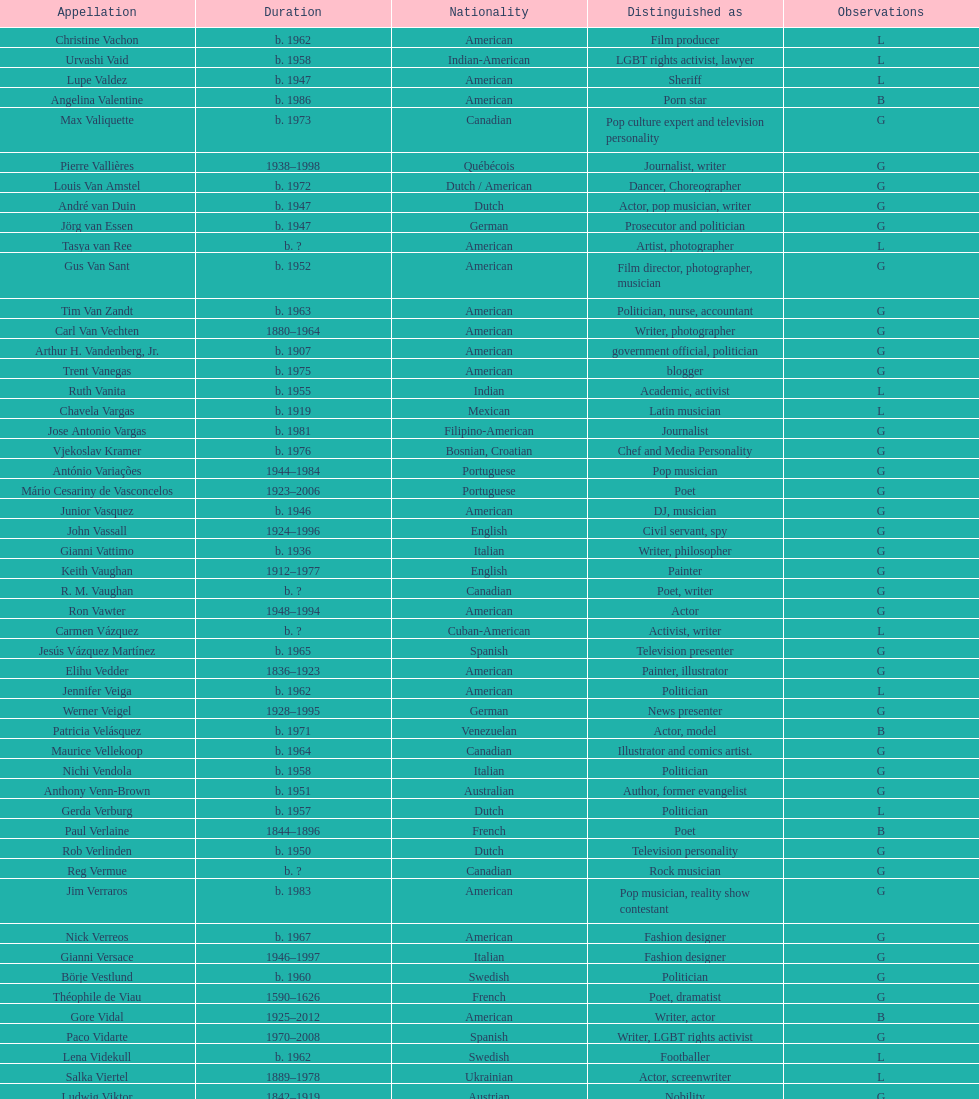Could you parse the entire table as a dict? {'header': ['Appellation', 'Duration', 'Nationality', 'Distinguished as', 'Observations'], 'rows': [['Christine Vachon', 'b. 1962', 'American', 'Film producer', 'L'], ['Urvashi Vaid', 'b. 1958', 'Indian-American', 'LGBT rights activist, lawyer', 'L'], ['Lupe Valdez', 'b. 1947', 'American', 'Sheriff', 'L'], ['Angelina Valentine', 'b. 1986', 'American', 'Porn star', 'B'], ['Max Valiquette', 'b. 1973', 'Canadian', 'Pop culture expert and television personality', 'G'], ['Pierre Vallières', '1938–1998', 'Québécois', 'Journalist, writer', 'G'], ['Louis Van Amstel', 'b. 1972', 'Dutch / American', 'Dancer, Choreographer', 'G'], ['André van Duin', 'b. 1947', 'Dutch', 'Actor, pop musician, writer', 'G'], ['Jörg van Essen', 'b. 1947', 'German', 'Prosecutor and politician', 'G'], ['Tasya van Ree', 'b.\xa0?', 'American', 'Artist, photographer', 'L'], ['Gus Van Sant', 'b. 1952', 'American', 'Film director, photographer, musician', 'G'], ['Tim Van Zandt', 'b. 1963', 'American', 'Politician, nurse, accountant', 'G'], ['Carl Van Vechten', '1880–1964', 'American', 'Writer, photographer', 'G'], ['Arthur H. Vandenberg, Jr.', 'b. 1907', 'American', 'government official, politician', 'G'], ['Trent Vanegas', 'b. 1975', 'American', 'blogger', 'G'], ['Ruth Vanita', 'b. 1955', 'Indian', 'Academic, activist', 'L'], ['Chavela Vargas', 'b. 1919', 'Mexican', 'Latin musician', 'L'], ['Jose Antonio Vargas', 'b. 1981', 'Filipino-American', 'Journalist', 'G'], ['Vjekoslav Kramer', 'b. 1976', 'Bosnian, Croatian', 'Chef and Media Personality', 'G'], ['António Variações', '1944–1984', 'Portuguese', 'Pop musician', 'G'], ['Mário Cesariny de Vasconcelos', '1923–2006', 'Portuguese', 'Poet', 'G'], ['Junior Vasquez', 'b. 1946', 'American', 'DJ, musician', 'G'], ['John Vassall', '1924–1996', 'English', 'Civil servant, spy', 'G'], ['Gianni Vattimo', 'b. 1936', 'Italian', 'Writer, philosopher', 'G'], ['Keith Vaughan', '1912–1977', 'English', 'Painter', 'G'], ['R. M. Vaughan', 'b.\xa0?', 'Canadian', 'Poet, writer', 'G'], ['Ron Vawter', '1948–1994', 'American', 'Actor', 'G'], ['Carmen Vázquez', 'b.\xa0?', 'Cuban-American', 'Activist, writer', 'L'], ['Jesús Vázquez Martínez', 'b. 1965', 'Spanish', 'Television presenter', 'G'], ['Elihu Vedder', '1836–1923', 'American', 'Painter, illustrator', 'G'], ['Jennifer Veiga', 'b. 1962', 'American', 'Politician', 'L'], ['Werner Veigel', '1928–1995', 'German', 'News presenter', 'G'], ['Patricia Velásquez', 'b. 1971', 'Venezuelan', 'Actor, model', 'B'], ['Maurice Vellekoop', 'b. 1964', 'Canadian', 'Illustrator and comics artist.', 'G'], ['Nichi Vendola', 'b. 1958', 'Italian', 'Politician', 'G'], ['Anthony Venn-Brown', 'b. 1951', 'Australian', 'Author, former evangelist', 'G'], ['Gerda Verburg', 'b. 1957', 'Dutch', 'Politician', 'L'], ['Paul Verlaine', '1844–1896', 'French', 'Poet', 'B'], ['Rob Verlinden', 'b. 1950', 'Dutch', 'Television personality', 'G'], ['Reg Vermue', 'b.\xa0?', 'Canadian', 'Rock musician', 'G'], ['Jim Verraros', 'b. 1983', 'American', 'Pop musician, reality show contestant', 'G'], ['Nick Verreos', 'b. 1967', 'American', 'Fashion designer', 'G'], ['Gianni Versace', '1946–1997', 'Italian', 'Fashion designer', 'G'], ['Börje Vestlund', 'b. 1960', 'Swedish', 'Politician', 'G'], ['Théophile de Viau', '1590–1626', 'French', 'Poet, dramatist', 'G'], ['Gore Vidal', '1925–2012', 'American', 'Writer, actor', 'B'], ['Paco Vidarte', '1970–2008', 'Spanish', 'Writer, LGBT rights activist', 'G'], ['Lena Videkull', 'b. 1962', 'Swedish', 'Footballer', 'L'], ['Salka Viertel', '1889–1978', 'Ukrainian', 'Actor, screenwriter', 'L'], ['Ludwig Viktor', '1842–1919', 'Austrian', 'Nobility', 'G'], ['Bruce Vilanch', 'b. 1948', 'American', 'Comedy writer, actor', 'G'], ['Tom Villard', '1953–1994', 'American', 'Actor', 'G'], ['José Villarrubia', 'b. 1961', 'American', 'Artist', 'G'], ['Xavier Villaurrutia', '1903–1950', 'Mexican', 'Poet, playwright', 'G'], ["Alain-Philippe Malagnac d'Argens de Villèle", '1950–2000', 'French', 'Aristocrat', 'G'], ['Norah Vincent', 'b.\xa0?', 'American', 'Journalist', 'L'], ['Donald Vining', '1917–1998', 'American', 'Writer', 'G'], ['Luchino Visconti', '1906–1976', 'Italian', 'Filmmaker', 'G'], ['Pavel Vítek', 'b. 1962', 'Czech', 'Pop musician, actor', 'G'], ['Renée Vivien', '1877–1909', 'English', 'Poet', 'L'], ['Claude Vivier', '1948–1983', 'Canadian', '20th century classical composer', 'G'], ['Taylor Vixen', 'b. 1983', 'American', 'Porn star', 'B'], ['Bruce Voeller', '1934–1994', 'American', 'HIV/AIDS researcher', 'G'], ['Paula Vogel', 'b. 1951', 'American', 'Playwright', 'L'], ['Julia Volkova', 'b. 1985', 'Russian', 'Singer', 'B'], ['Jörg van Essen', 'b. 1947', 'German', 'Politician', 'G'], ['Ole von Beust', 'b. 1955', 'German', 'Politician', 'G'], ['Wilhelm von Gloeden', '1856–1931', 'German', 'Photographer', 'G'], ['Rosa von Praunheim', 'b. 1942', 'German', 'Film director', 'G'], ['Kurt von Ruffin', 'b. 1901–1996', 'German', 'Holocaust survivor', 'G'], ['Hella von Sinnen', 'b. 1959', 'German', 'Comedian', 'L'], ['Daniel Vosovic', 'b. 1981', 'American', 'Fashion designer', 'G'], ['Delwin Vriend', 'b. 1966', 'Canadian', 'LGBT rights activist', 'G']]} Who lived longer, van vechten or variacoes? Van Vechten. 